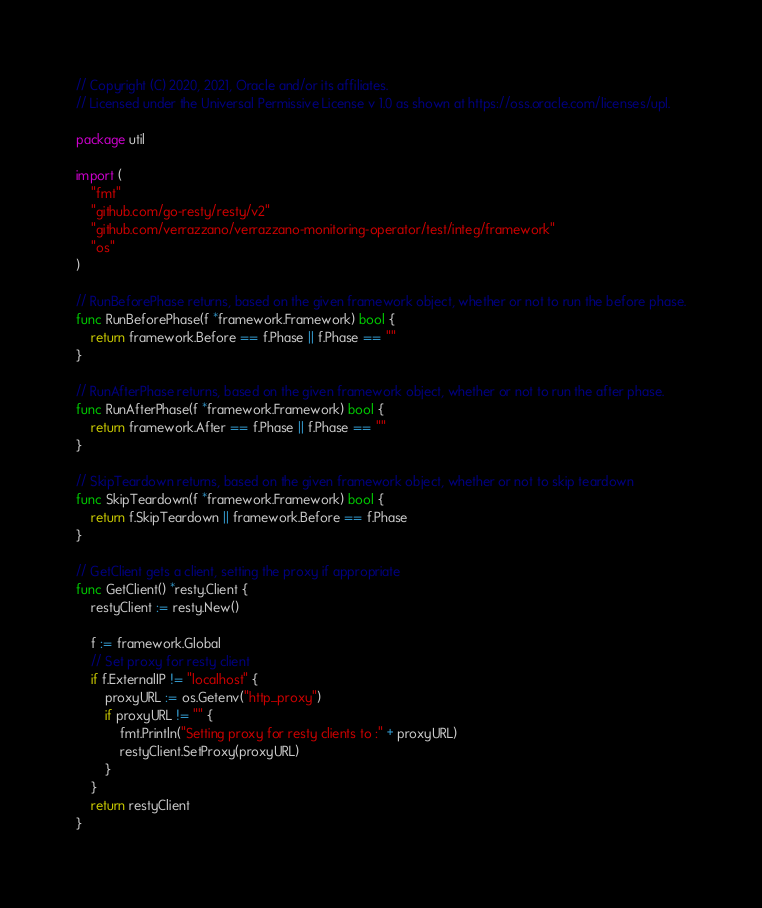<code> <loc_0><loc_0><loc_500><loc_500><_Go_>// Copyright (C) 2020, 2021, Oracle and/or its affiliates.
// Licensed under the Universal Permissive License v 1.0 as shown at https://oss.oracle.com/licenses/upl.

package util

import (
	"fmt"
	"github.com/go-resty/resty/v2"
	"github.com/verrazzano/verrazzano-monitoring-operator/test/integ/framework"
	"os"
)

// RunBeforePhase returns, based on the given framework object, whether or not to run the before phase.
func RunBeforePhase(f *framework.Framework) bool {
	return framework.Before == f.Phase || f.Phase == ""
}

// RunAfterPhase returns, based on the given framework object, whether or not to run the after phase.
func RunAfterPhase(f *framework.Framework) bool {
	return framework.After == f.Phase || f.Phase == ""
}

// SkipTeardown returns, based on the given framework object, whether or not to skip teardown
func SkipTeardown(f *framework.Framework) bool {
	return f.SkipTeardown || framework.Before == f.Phase
}

// GetClient gets a client, setting the proxy if appropriate
func GetClient() *resty.Client {
	restyClient := resty.New()

	f := framework.Global
	// Set proxy for resty client
	if f.ExternalIP != "localhost" {
		proxyURL := os.Getenv("http_proxy")
		if proxyURL != "" {
			fmt.Println("Setting proxy for resty clients to :" + proxyURL)
			restyClient.SetProxy(proxyURL)
		}
	}
	return restyClient
}
</code> 